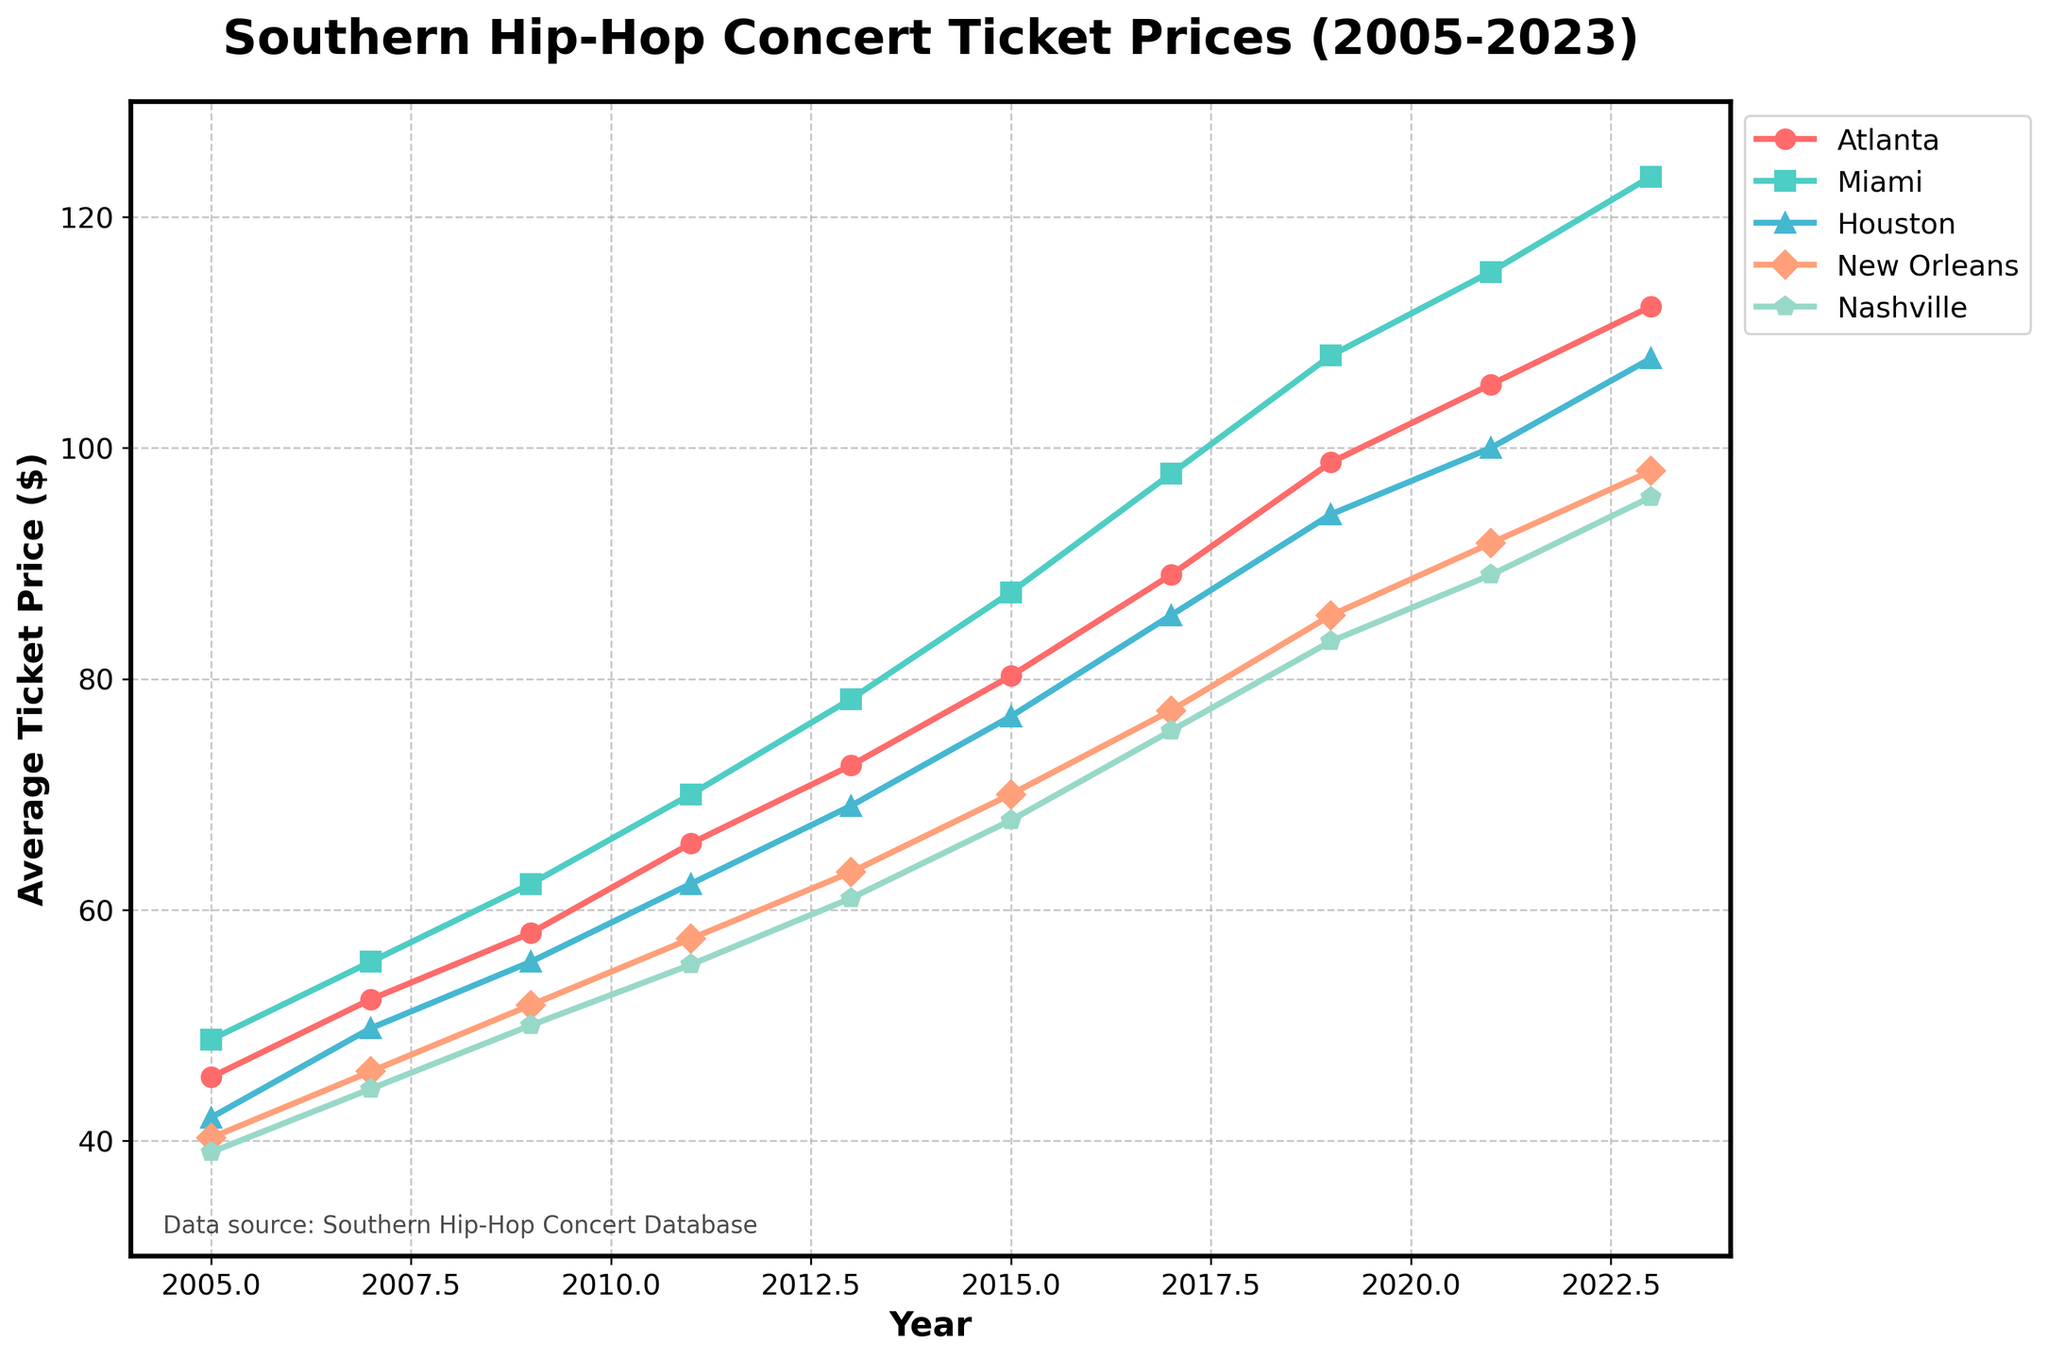What's the trend of average ticket prices in Atlanta from 2005 to 2023? The line representing Atlanta shows a consistent increase from 45.50 in 2005 to 112.25 in 2023. To confirm, each plotted point's value rises progressively over the years.
Answer: Consistently increasing Which city has the highest average ticket price in 2023? The line chart shows that Miami's line is positioned the highest in 2023 amongst all cities, indicating it has the highest ticket price.
Answer: Miami How do the average ticket prices for Houston and Nashville compare in 2019? By inspecting the plotted points for Houston and Nashville on the 2019 x-axis, Houston is at 94.25 while Nashville is at 83.25. Thus, Houston's price is higher.
Answer: Houston's price is higher Calculate the average ticket price of all cities in 2005. Sum the ticket prices in 2005: (45.50 + 48.75 + 42.00 + 40.25 + 39.00) = 215.50. Divide by the number of cities (5): 215.50 / 5 = 43.10.
Answer: 43.10 Which city had the fastest growth in ticket prices from 2005 to 2023? Calculate the difference between 2023 and 2005 for each city: Atlanta (112.25-45.50), Miami (123.50-48.75), Houston (107.75-42.00), New Orleans (98.00-40.25), and Nashville (95.75-39.00). The largest difference is for Miami: 123.50 - 48.75 = 74.75.
Answer: Miami In which year did Atlanta's average ticket price first exceed $50? The value of Atlanta's average ticket price exceeds $50 in 2007, where it's listed at 52.25.
Answer: 2007 When comparing New Orleans and Nashville, which city had lower ticket prices from 2005 to 2023 and in how many years did it happen? For each year from 2005 to 2023, compare New Orleans and Nashville's ticket prices: In 2005 (40.25 vs 39.00), 2007 (46.00 vs 44.50), 2009 (51.75 vs 50.00), 2011 (57.50 vs 55.25), 2013 (63.25 vs 61.00), 2015 (70.00 vs 67.75), 2017 (77.25 vs 75.50), 2019 (85.50 vs 83.25), 2021 (91.75 vs 89.00), 2023 (98.00 vs 95.75). Nashville was lower every year.
Answer: In all 10 years What is the overall trend in ticket prices across all southern states presented? Inspecting all plotted lines, each shows a consistent upward trend from 2005 to 2023.
Answer: Consistently increasing Between 2005 and 2007, which city experienced the highest percentage increase in ticket prices? Calculate percentage increase for each city: Atlanta (52.25-45.50)/45.50*100 ≈ 14.84%, Miami (55.50-48.75)/48.75*100 ≈ 13.85%, Houston (49.75-42.00)/42.00*100 ≈ 18.45%, New Orleans (46.00-40.25)/40.25*100 ≈ 14.28%, Nashville (44.50-39.00)/39.00*100 ≈ 14.10%. Houston has the highest percentage increase.
Answer: Houston 